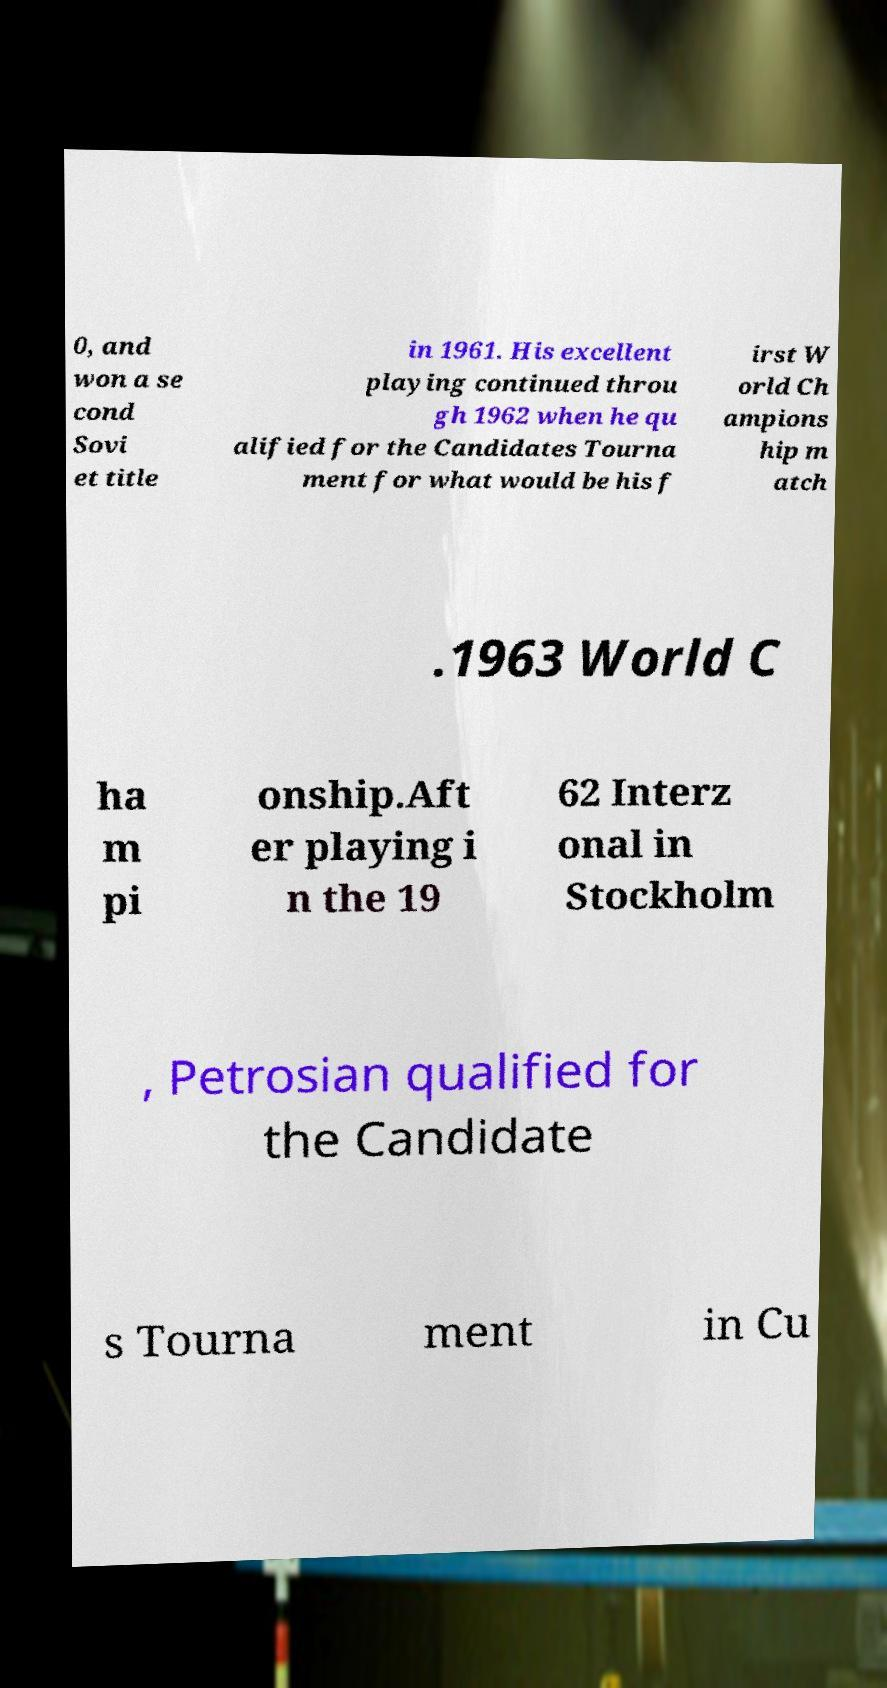Please read and relay the text visible in this image. What does it say? 0, and won a se cond Sovi et title in 1961. His excellent playing continued throu gh 1962 when he qu alified for the Candidates Tourna ment for what would be his f irst W orld Ch ampions hip m atch .1963 World C ha m pi onship.Aft er playing i n the 19 62 Interz onal in Stockholm , Petrosian qualified for the Candidate s Tourna ment in Cu 